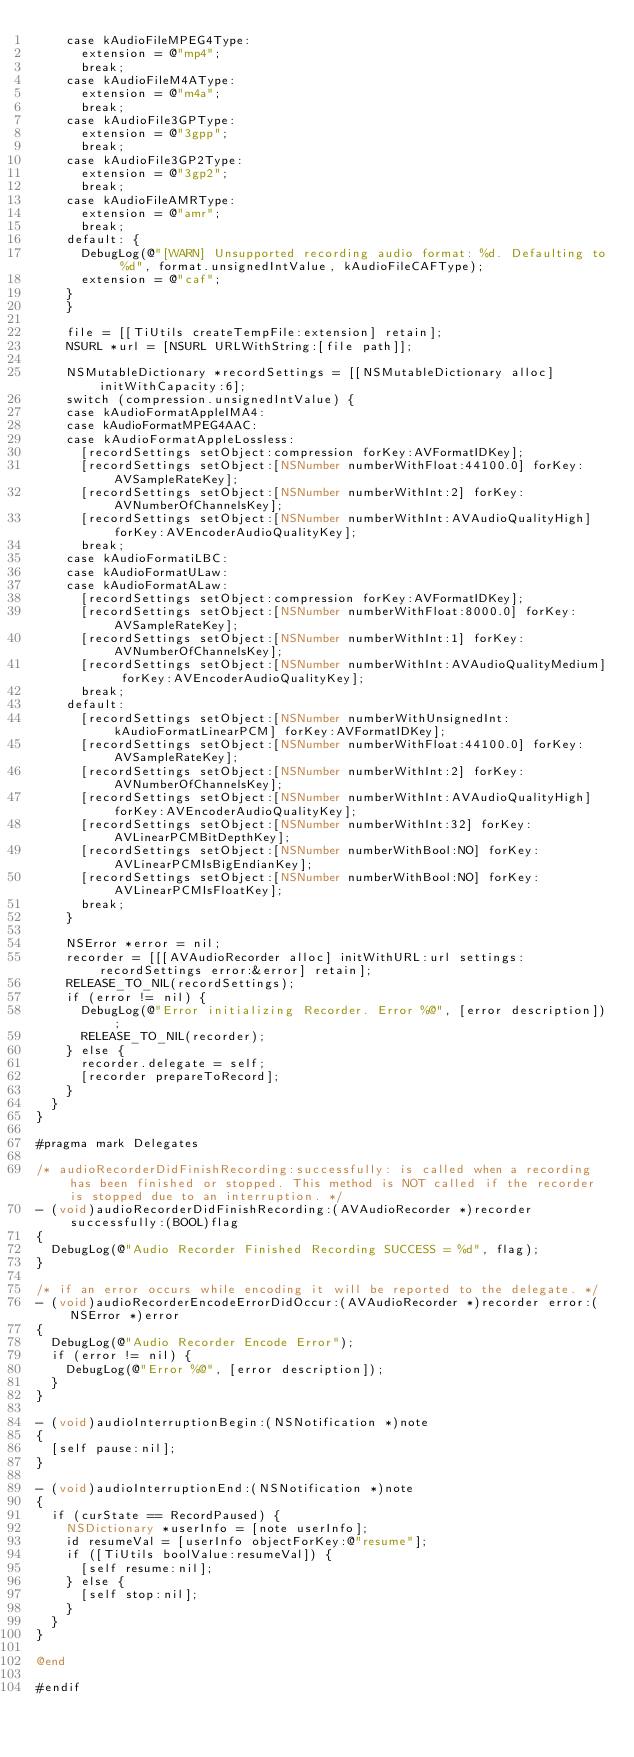<code> <loc_0><loc_0><loc_500><loc_500><_ObjectiveC_>    case kAudioFileMPEG4Type:
      extension = @"mp4";
      break;
    case kAudioFileM4AType:
      extension = @"m4a";
      break;
    case kAudioFile3GPType:
      extension = @"3gpp";
      break;
    case kAudioFile3GP2Type:
      extension = @"3gp2";
      break;
    case kAudioFileAMRType:
      extension = @"amr";
      break;
    default: {
      DebugLog(@"[WARN] Unsupported recording audio format: %d. Defaulting to %d", format.unsignedIntValue, kAudioFileCAFType);
      extension = @"caf";
    }
    }

    file = [[TiUtils createTempFile:extension] retain];
    NSURL *url = [NSURL URLWithString:[file path]];

    NSMutableDictionary *recordSettings = [[NSMutableDictionary alloc] initWithCapacity:6];
    switch (compression.unsignedIntValue) {
    case kAudioFormatAppleIMA4:
    case kAudioFormatMPEG4AAC:
    case kAudioFormatAppleLossless:
      [recordSettings setObject:compression forKey:AVFormatIDKey];
      [recordSettings setObject:[NSNumber numberWithFloat:44100.0] forKey:AVSampleRateKey];
      [recordSettings setObject:[NSNumber numberWithInt:2] forKey:AVNumberOfChannelsKey];
      [recordSettings setObject:[NSNumber numberWithInt:AVAudioQualityHigh] forKey:AVEncoderAudioQualityKey];
      break;
    case kAudioFormatiLBC:
    case kAudioFormatULaw:
    case kAudioFormatALaw:
      [recordSettings setObject:compression forKey:AVFormatIDKey];
      [recordSettings setObject:[NSNumber numberWithFloat:8000.0] forKey:AVSampleRateKey];
      [recordSettings setObject:[NSNumber numberWithInt:1] forKey:AVNumberOfChannelsKey];
      [recordSettings setObject:[NSNumber numberWithInt:AVAudioQualityMedium] forKey:AVEncoderAudioQualityKey];
      break;
    default:
      [recordSettings setObject:[NSNumber numberWithUnsignedInt:kAudioFormatLinearPCM] forKey:AVFormatIDKey];
      [recordSettings setObject:[NSNumber numberWithFloat:44100.0] forKey:AVSampleRateKey];
      [recordSettings setObject:[NSNumber numberWithInt:2] forKey:AVNumberOfChannelsKey];
      [recordSettings setObject:[NSNumber numberWithInt:AVAudioQualityHigh] forKey:AVEncoderAudioQualityKey];
      [recordSettings setObject:[NSNumber numberWithInt:32] forKey:AVLinearPCMBitDepthKey];
      [recordSettings setObject:[NSNumber numberWithBool:NO] forKey:AVLinearPCMIsBigEndianKey];
      [recordSettings setObject:[NSNumber numberWithBool:NO] forKey:AVLinearPCMIsFloatKey];
      break;
    }

    NSError *error = nil;
    recorder = [[[AVAudioRecorder alloc] initWithURL:url settings:recordSettings error:&error] retain];
    RELEASE_TO_NIL(recordSettings);
    if (error != nil) {
      DebugLog(@"Error initializing Recorder. Error %@", [error description]);
      RELEASE_TO_NIL(recorder);
    } else {
      recorder.delegate = self;
      [recorder prepareToRecord];
    }
  }
}

#pragma mark Delegates

/* audioRecorderDidFinishRecording:successfully: is called when a recording has been finished or stopped. This method is NOT called if the recorder is stopped due to an interruption. */
- (void)audioRecorderDidFinishRecording:(AVAudioRecorder *)recorder successfully:(BOOL)flag
{
  DebugLog(@"Audio Recorder Finished Recording SUCCESS = %d", flag);
}

/* if an error occurs while encoding it will be reported to the delegate. */
- (void)audioRecorderEncodeErrorDidOccur:(AVAudioRecorder *)recorder error:(NSError *)error
{
  DebugLog(@"Audio Recorder Encode Error");
  if (error != nil) {
    DebugLog(@"Error %@", [error description]);
  }
}

- (void)audioInterruptionBegin:(NSNotification *)note
{
  [self pause:nil];
}

- (void)audioInterruptionEnd:(NSNotification *)note
{
  if (curState == RecordPaused) {
    NSDictionary *userInfo = [note userInfo];
    id resumeVal = [userInfo objectForKey:@"resume"];
    if ([TiUtils boolValue:resumeVal]) {
      [self resume:nil];
    } else {
      [self stop:nil];
    }
  }
}

@end

#endif
</code> 